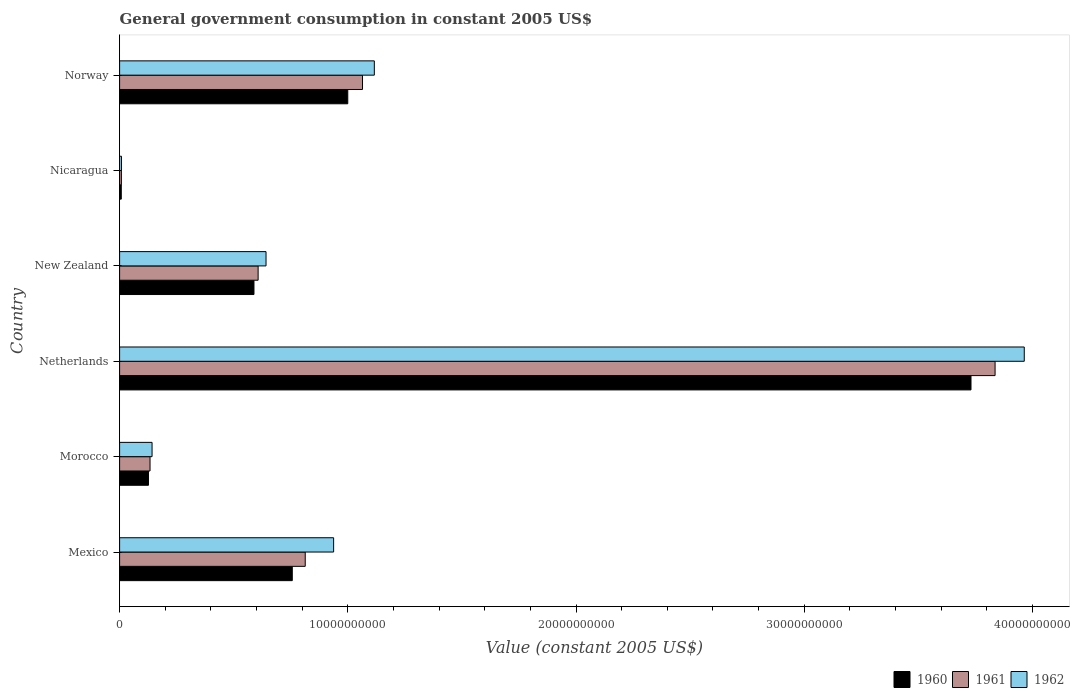How many different coloured bars are there?
Make the answer very short. 3. How many groups of bars are there?
Provide a short and direct response. 6. How many bars are there on the 3rd tick from the top?
Provide a succinct answer. 3. How many bars are there on the 6th tick from the bottom?
Your response must be concise. 3. What is the label of the 3rd group of bars from the top?
Offer a terse response. New Zealand. In how many cases, is the number of bars for a given country not equal to the number of legend labels?
Keep it short and to the point. 0. What is the government conusmption in 1961 in Norway?
Provide a short and direct response. 1.06e+1. Across all countries, what is the maximum government conusmption in 1960?
Provide a short and direct response. 3.73e+1. Across all countries, what is the minimum government conusmption in 1962?
Your answer should be compact. 8.22e+07. In which country was the government conusmption in 1961 minimum?
Provide a short and direct response. Nicaragua. What is the total government conusmption in 1960 in the graph?
Your response must be concise. 6.21e+1. What is the difference between the government conusmption in 1961 in Morocco and that in New Zealand?
Your answer should be very brief. -4.74e+09. What is the difference between the government conusmption in 1961 in New Zealand and the government conusmption in 1962 in Morocco?
Give a very brief answer. 4.65e+09. What is the average government conusmption in 1962 per country?
Your answer should be compact. 1.14e+1. What is the difference between the government conusmption in 1961 and government conusmption in 1962 in Mexico?
Your answer should be very brief. -1.24e+09. What is the ratio of the government conusmption in 1961 in Mexico to that in Morocco?
Your answer should be very brief. 6.1. Is the difference between the government conusmption in 1961 in Mexico and Netherlands greater than the difference between the government conusmption in 1962 in Mexico and Netherlands?
Give a very brief answer. Yes. What is the difference between the highest and the second highest government conusmption in 1960?
Your answer should be compact. 2.73e+1. What is the difference between the highest and the lowest government conusmption in 1962?
Offer a terse response. 3.96e+1. What does the 1st bar from the bottom in Morocco represents?
Provide a short and direct response. 1960. How many bars are there?
Ensure brevity in your answer.  18. How many countries are there in the graph?
Your answer should be compact. 6. Does the graph contain any zero values?
Ensure brevity in your answer.  No. What is the title of the graph?
Ensure brevity in your answer.  General government consumption in constant 2005 US$. Does "1962" appear as one of the legend labels in the graph?
Ensure brevity in your answer.  Yes. What is the label or title of the X-axis?
Provide a succinct answer. Value (constant 2005 US$). What is the label or title of the Y-axis?
Your response must be concise. Country. What is the Value (constant 2005 US$) of 1960 in Mexico?
Keep it short and to the point. 7.57e+09. What is the Value (constant 2005 US$) in 1961 in Mexico?
Your response must be concise. 8.13e+09. What is the Value (constant 2005 US$) of 1962 in Mexico?
Your answer should be compact. 9.38e+09. What is the Value (constant 2005 US$) in 1960 in Morocco?
Your answer should be very brief. 1.27e+09. What is the Value (constant 2005 US$) in 1961 in Morocco?
Your answer should be compact. 1.33e+09. What is the Value (constant 2005 US$) in 1962 in Morocco?
Your answer should be very brief. 1.42e+09. What is the Value (constant 2005 US$) of 1960 in Netherlands?
Keep it short and to the point. 3.73e+1. What is the Value (constant 2005 US$) in 1961 in Netherlands?
Offer a terse response. 3.84e+1. What is the Value (constant 2005 US$) in 1962 in Netherlands?
Make the answer very short. 3.96e+1. What is the Value (constant 2005 US$) of 1960 in New Zealand?
Your answer should be very brief. 5.89e+09. What is the Value (constant 2005 US$) in 1961 in New Zealand?
Ensure brevity in your answer.  6.07e+09. What is the Value (constant 2005 US$) in 1962 in New Zealand?
Your answer should be very brief. 6.42e+09. What is the Value (constant 2005 US$) in 1960 in Nicaragua?
Offer a terse response. 7.32e+07. What is the Value (constant 2005 US$) of 1961 in Nicaragua?
Make the answer very short. 7.81e+07. What is the Value (constant 2005 US$) of 1962 in Nicaragua?
Give a very brief answer. 8.22e+07. What is the Value (constant 2005 US$) of 1960 in Norway?
Provide a succinct answer. 1.00e+1. What is the Value (constant 2005 US$) in 1961 in Norway?
Your answer should be compact. 1.06e+1. What is the Value (constant 2005 US$) in 1962 in Norway?
Offer a terse response. 1.12e+1. Across all countries, what is the maximum Value (constant 2005 US$) in 1960?
Your answer should be compact. 3.73e+1. Across all countries, what is the maximum Value (constant 2005 US$) of 1961?
Your answer should be very brief. 3.84e+1. Across all countries, what is the maximum Value (constant 2005 US$) of 1962?
Your answer should be compact. 3.96e+1. Across all countries, what is the minimum Value (constant 2005 US$) of 1960?
Your response must be concise. 7.32e+07. Across all countries, what is the minimum Value (constant 2005 US$) in 1961?
Make the answer very short. 7.81e+07. Across all countries, what is the minimum Value (constant 2005 US$) of 1962?
Your answer should be compact. 8.22e+07. What is the total Value (constant 2005 US$) in 1960 in the graph?
Your answer should be compact. 6.21e+1. What is the total Value (constant 2005 US$) in 1961 in the graph?
Ensure brevity in your answer.  6.46e+1. What is the total Value (constant 2005 US$) in 1962 in the graph?
Keep it short and to the point. 6.81e+1. What is the difference between the Value (constant 2005 US$) of 1960 in Mexico and that in Morocco?
Your response must be concise. 6.30e+09. What is the difference between the Value (constant 2005 US$) in 1961 in Mexico and that in Morocco?
Provide a succinct answer. 6.80e+09. What is the difference between the Value (constant 2005 US$) in 1962 in Mexico and that in Morocco?
Offer a terse response. 7.96e+09. What is the difference between the Value (constant 2005 US$) of 1960 in Mexico and that in Netherlands?
Provide a succinct answer. -2.97e+1. What is the difference between the Value (constant 2005 US$) of 1961 in Mexico and that in Netherlands?
Give a very brief answer. -3.02e+1. What is the difference between the Value (constant 2005 US$) in 1962 in Mexico and that in Netherlands?
Your answer should be compact. -3.03e+1. What is the difference between the Value (constant 2005 US$) in 1960 in Mexico and that in New Zealand?
Your answer should be compact. 1.68e+09. What is the difference between the Value (constant 2005 US$) of 1961 in Mexico and that in New Zealand?
Your answer should be compact. 2.06e+09. What is the difference between the Value (constant 2005 US$) of 1962 in Mexico and that in New Zealand?
Make the answer very short. 2.96e+09. What is the difference between the Value (constant 2005 US$) of 1960 in Mexico and that in Nicaragua?
Provide a succinct answer. 7.49e+09. What is the difference between the Value (constant 2005 US$) in 1961 in Mexico and that in Nicaragua?
Your answer should be compact. 8.06e+09. What is the difference between the Value (constant 2005 US$) of 1962 in Mexico and that in Nicaragua?
Your answer should be very brief. 9.30e+09. What is the difference between the Value (constant 2005 US$) in 1960 in Mexico and that in Norway?
Your answer should be very brief. -2.43e+09. What is the difference between the Value (constant 2005 US$) of 1961 in Mexico and that in Norway?
Ensure brevity in your answer.  -2.51e+09. What is the difference between the Value (constant 2005 US$) in 1962 in Mexico and that in Norway?
Your answer should be compact. -1.78e+09. What is the difference between the Value (constant 2005 US$) in 1960 in Morocco and that in Netherlands?
Your answer should be compact. -3.60e+1. What is the difference between the Value (constant 2005 US$) in 1961 in Morocco and that in Netherlands?
Keep it short and to the point. -3.70e+1. What is the difference between the Value (constant 2005 US$) of 1962 in Morocco and that in Netherlands?
Offer a very short reply. -3.82e+1. What is the difference between the Value (constant 2005 US$) of 1960 in Morocco and that in New Zealand?
Provide a succinct answer. -4.62e+09. What is the difference between the Value (constant 2005 US$) of 1961 in Morocco and that in New Zealand?
Give a very brief answer. -4.74e+09. What is the difference between the Value (constant 2005 US$) of 1962 in Morocco and that in New Zealand?
Offer a terse response. -4.99e+09. What is the difference between the Value (constant 2005 US$) in 1960 in Morocco and that in Nicaragua?
Provide a succinct answer. 1.19e+09. What is the difference between the Value (constant 2005 US$) of 1961 in Morocco and that in Nicaragua?
Keep it short and to the point. 1.26e+09. What is the difference between the Value (constant 2005 US$) of 1962 in Morocco and that in Nicaragua?
Offer a very short reply. 1.34e+09. What is the difference between the Value (constant 2005 US$) in 1960 in Morocco and that in Norway?
Your answer should be compact. -8.73e+09. What is the difference between the Value (constant 2005 US$) of 1961 in Morocco and that in Norway?
Provide a short and direct response. -9.31e+09. What is the difference between the Value (constant 2005 US$) of 1962 in Morocco and that in Norway?
Offer a very short reply. -9.74e+09. What is the difference between the Value (constant 2005 US$) in 1960 in Netherlands and that in New Zealand?
Provide a short and direct response. 3.14e+1. What is the difference between the Value (constant 2005 US$) in 1961 in Netherlands and that in New Zealand?
Give a very brief answer. 3.23e+1. What is the difference between the Value (constant 2005 US$) in 1962 in Netherlands and that in New Zealand?
Keep it short and to the point. 3.32e+1. What is the difference between the Value (constant 2005 US$) in 1960 in Netherlands and that in Nicaragua?
Give a very brief answer. 3.72e+1. What is the difference between the Value (constant 2005 US$) of 1961 in Netherlands and that in Nicaragua?
Make the answer very short. 3.83e+1. What is the difference between the Value (constant 2005 US$) in 1962 in Netherlands and that in Nicaragua?
Offer a very short reply. 3.96e+1. What is the difference between the Value (constant 2005 US$) of 1960 in Netherlands and that in Norway?
Make the answer very short. 2.73e+1. What is the difference between the Value (constant 2005 US$) of 1961 in Netherlands and that in Norway?
Your response must be concise. 2.77e+1. What is the difference between the Value (constant 2005 US$) in 1962 in Netherlands and that in Norway?
Offer a very short reply. 2.85e+1. What is the difference between the Value (constant 2005 US$) of 1960 in New Zealand and that in Nicaragua?
Keep it short and to the point. 5.81e+09. What is the difference between the Value (constant 2005 US$) of 1961 in New Zealand and that in Nicaragua?
Your answer should be very brief. 5.99e+09. What is the difference between the Value (constant 2005 US$) in 1962 in New Zealand and that in Nicaragua?
Keep it short and to the point. 6.33e+09. What is the difference between the Value (constant 2005 US$) of 1960 in New Zealand and that in Norway?
Make the answer very short. -4.11e+09. What is the difference between the Value (constant 2005 US$) of 1961 in New Zealand and that in Norway?
Offer a very short reply. -4.57e+09. What is the difference between the Value (constant 2005 US$) in 1962 in New Zealand and that in Norway?
Provide a succinct answer. -4.75e+09. What is the difference between the Value (constant 2005 US$) in 1960 in Nicaragua and that in Norway?
Offer a very short reply. -9.92e+09. What is the difference between the Value (constant 2005 US$) in 1961 in Nicaragua and that in Norway?
Give a very brief answer. -1.06e+1. What is the difference between the Value (constant 2005 US$) in 1962 in Nicaragua and that in Norway?
Ensure brevity in your answer.  -1.11e+1. What is the difference between the Value (constant 2005 US$) of 1960 in Mexico and the Value (constant 2005 US$) of 1961 in Morocco?
Keep it short and to the point. 6.23e+09. What is the difference between the Value (constant 2005 US$) in 1960 in Mexico and the Value (constant 2005 US$) in 1962 in Morocco?
Give a very brief answer. 6.14e+09. What is the difference between the Value (constant 2005 US$) of 1961 in Mexico and the Value (constant 2005 US$) of 1962 in Morocco?
Give a very brief answer. 6.71e+09. What is the difference between the Value (constant 2005 US$) of 1960 in Mexico and the Value (constant 2005 US$) of 1961 in Netherlands?
Ensure brevity in your answer.  -3.08e+1. What is the difference between the Value (constant 2005 US$) in 1960 in Mexico and the Value (constant 2005 US$) in 1962 in Netherlands?
Your answer should be very brief. -3.21e+1. What is the difference between the Value (constant 2005 US$) of 1961 in Mexico and the Value (constant 2005 US$) of 1962 in Netherlands?
Your answer should be very brief. -3.15e+1. What is the difference between the Value (constant 2005 US$) in 1960 in Mexico and the Value (constant 2005 US$) in 1961 in New Zealand?
Offer a terse response. 1.50e+09. What is the difference between the Value (constant 2005 US$) of 1960 in Mexico and the Value (constant 2005 US$) of 1962 in New Zealand?
Offer a very short reply. 1.15e+09. What is the difference between the Value (constant 2005 US$) in 1961 in Mexico and the Value (constant 2005 US$) in 1962 in New Zealand?
Offer a very short reply. 1.72e+09. What is the difference between the Value (constant 2005 US$) of 1960 in Mexico and the Value (constant 2005 US$) of 1961 in Nicaragua?
Provide a succinct answer. 7.49e+09. What is the difference between the Value (constant 2005 US$) in 1960 in Mexico and the Value (constant 2005 US$) in 1962 in Nicaragua?
Your answer should be very brief. 7.48e+09. What is the difference between the Value (constant 2005 US$) of 1961 in Mexico and the Value (constant 2005 US$) of 1962 in Nicaragua?
Keep it short and to the point. 8.05e+09. What is the difference between the Value (constant 2005 US$) of 1960 in Mexico and the Value (constant 2005 US$) of 1961 in Norway?
Provide a succinct answer. -3.08e+09. What is the difference between the Value (constant 2005 US$) in 1960 in Mexico and the Value (constant 2005 US$) in 1962 in Norway?
Offer a very short reply. -3.60e+09. What is the difference between the Value (constant 2005 US$) of 1961 in Mexico and the Value (constant 2005 US$) of 1962 in Norway?
Offer a very short reply. -3.03e+09. What is the difference between the Value (constant 2005 US$) of 1960 in Morocco and the Value (constant 2005 US$) of 1961 in Netherlands?
Give a very brief answer. -3.71e+1. What is the difference between the Value (constant 2005 US$) of 1960 in Morocco and the Value (constant 2005 US$) of 1962 in Netherlands?
Make the answer very short. -3.84e+1. What is the difference between the Value (constant 2005 US$) of 1961 in Morocco and the Value (constant 2005 US$) of 1962 in Netherlands?
Your answer should be very brief. -3.83e+1. What is the difference between the Value (constant 2005 US$) in 1960 in Morocco and the Value (constant 2005 US$) in 1961 in New Zealand?
Give a very brief answer. -4.80e+09. What is the difference between the Value (constant 2005 US$) of 1960 in Morocco and the Value (constant 2005 US$) of 1962 in New Zealand?
Give a very brief answer. -5.15e+09. What is the difference between the Value (constant 2005 US$) of 1961 in Morocco and the Value (constant 2005 US$) of 1962 in New Zealand?
Your answer should be very brief. -5.08e+09. What is the difference between the Value (constant 2005 US$) of 1960 in Morocco and the Value (constant 2005 US$) of 1961 in Nicaragua?
Offer a terse response. 1.19e+09. What is the difference between the Value (constant 2005 US$) in 1960 in Morocco and the Value (constant 2005 US$) in 1962 in Nicaragua?
Your answer should be compact. 1.18e+09. What is the difference between the Value (constant 2005 US$) in 1961 in Morocco and the Value (constant 2005 US$) in 1962 in Nicaragua?
Give a very brief answer. 1.25e+09. What is the difference between the Value (constant 2005 US$) in 1960 in Morocco and the Value (constant 2005 US$) in 1961 in Norway?
Provide a succinct answer. -9.38e+09. What is the difference between the Value (constant 2005 US$) of 1960 in Morocco and the Value (constant 2005 US$) of 1962 in Norway?
Provide a short and direct response. -9.90e+09. What is the difference between the Value (constant 2005 US$) in 1961 in Morocco and the Value (constant 2005 US$) in 1962 in Norway?
Offer a very short reply. -9.83e+09. What is the difference between the Value (constant 2005 US$) of 1960 in Netherlands and the Value (constant 2005 US$) of 1961 in New Zealand?
Offer a terse response. 3.12e+1. What is the difference between the Value (constant 2005 US$) in 1960 in Netherlands and the Value (constant 2005 US$) in 1962 in New Zealand?
Offer a very short reply. 3.09e+1. What is the difference between the Value (constant 2005 US$) of 1961 in Netherlands and the Value (constant 2005 US$) of 1962 in New Zealand?
Your answer should be very brief. 3.19e+1. What is the difference between the Value (constant 2005 US$) of 1960 in Netherlands and the Value (constant 2005 US$) of 1961 in Nicaragua?
Give a very brief answer. 3.72e+1. What is the difference between the Value (constant 2005 US$) of 1960 in Netherlands and the Value (constant 2005 US$) of 1962 in Nicaragua?
Offer a very short reply. 3.72e+1. What is the difference between the Value (constant 2005 US$) of 1961 in Netherlands and the Value (constant 2005 US$) of 1962 in Nicaragua?
Provide a succinct answer. 3.83e+1. What is the difference between the Value (constant 2005 US$) in 1960 in Netherlands and the Value (constant 2005 US$) in 1961 in Norway?
Your answer should be compact. 2.67e+1. What is the difference between the Value (constant 2005 US$) of 1960 in Netherlands and the Value (constant 2005 US$) of 1962 in Norway?
Keep it short and to the point. 2.61e+1. What is the difference between the Value (constant 2005 US$) of 1961 in Netherlands and the Value (constant 2005 US$) of 1962 in Norway?
Give a very brief answer. 2.72e+1. What is the difference between the Value (constant 2005 US$) in 1960 in New Zealand and the Value (constant 2005 US$) in 1961 in Nicaragua?
Provide a succinct answer. 5.81e+09. What is the difference between the Value (constant 2005 US$) in 1960 in New Zealand and the Value (constant 2005 US$) in 1962 in Nicaragua?
Offer a very short reply. 5.81e+09. What is the difference between the Value (constant 2005 US$) in 1961 in New Zealand and the Value (constant 2005 US$) in 1962 in Nicaragua?
Provide a succinct answer. 5.99e+09. What is the difference between the Value (constant 2005 US$) in 1960 in New Zealand and the Value (constant 2005 US$) in 1961 in Norway?
Make the answer very short. -4.76e+09. What is the difference between the Value (constant 2005 US$) in 1960 in New Zealand and the Value (constant 2005 US$) in 1962 in Norway?
Make the answer very short. -5.27e+09. What is the difference between the Value (constant 2005 US$) in 1961 in New Zealand and the Value (constant 2005 US$) in 1962 in Norway?
Ensure brevity in your answer.  -5.09e+09. What is the difference between the Value (constant 2005 US$) in 1960 in Nicaragua and the Value (constant 2005 US$) in 1961 in Norway?
Give a very brief answer. -1.06e+1. What is the difference between the Value (constant 2005 US$) in 1960 in Nicaragua and the Value (constant 2005 US$) in 1962 in Norway?
Provide a succinct answer. -1.11e+1. What is the difference between the Value (constant 2005 US$) of 1961 in Nicaragua and the Value (constant 2005 US$) of 1962 in Norway?
Give a very brief answer. -1.11e+1. What is the average Value (constant 2005 US$) in 1960 per country?
Your answer should be compact. 1.03e+1. What is the average Value (constant 2005 US$) in 1961 per country?
Make the answer very short. 1.08e+1. What is the average Value (constant 2005 US$) of 1962 per country?
Provide a succinct answer. 1.14e+1. What is the difference between the Value (constant 2005 US$) in 1960 and Value (constant 2005 US$) in 1961 in Mexico?
Provide a succinct answer. -5.68e+08. What is the difference between the Value (constant 2005 US$) of 1960 and Value (constant 2005 US$) of 1962 in Mexico?
Provide a short and direct response. -1.81e+09. What is the difference between the Value (constant 2005 US$) in 1961 and Value (constant 2005 US$) in 1962 in Mexico?
Your answer should be compact. -1.24e+09. What is the difference between the Value (constant 2005 US$) of 1960 and Value (constant 2005 US$) of 1961 in Morocco?
Provide a succinct answer. -6.82e+07. What is the difference between the Value (constant 2005 US$) in 1960 and Value (constant 2005 US$) in 1962 in Morocco?
Your response must be concise. -1.57e+08. What is the difference between the Value (constant 2005 US$) in 1961 and Value (constant 2005 US$) in 1962 in Morocco?
Your answer should be very brief. -8.90e+07. What is the difference between the Value (constant 2005 US$) in 1960 and Value (constant 2005 US$) in 1961 in Netherlands?
Offer a terse response. -1.06e+09. What is the difference between the Value (constant 2005 US$) in 1960 and Value (constant 2005 US$) in 1962 in Netherlands?
Ensure brevity in your answer.  -2.33e+09. What is the difference between the Value (constant 2005 US$) of 1961 and Value (constant 2005 US$) of 1962 in Netherlands?
Your response must be concise. -1.28e+09. What is the difference between the Value (constant 2005 US$) in 1960 and Value (constant 2005 US$) in 1961 in New Zealand?
Provide a succinct answer. -1.82e+08. What is the difference between the Value (constant 2005 US$) in 1960 and Value (constant 2005 US$) in 1962 in New Zealand?
Your answer should be very brief. -5.28e+08. What is the difference between the Value (constant 2005 US$) of 1961 and Value (constant 2005 US$) of 1962 in New Zealand?
Ensure brevity in your answer.  -3.46e+08. What is the difference between the Value (constant 2005 US$) of 1960 and Value (constant 2005 US$) of 1961 in Nicaragua?
Your answer should be very brief. -4.90e+06. What is the difference between the Value (constant 2005 US$) of 1960 and Value (constant 2005 US$) of 1962 in Nicaragua?
Ensure brevity in your answer.  -8.94e+06. What is the difference between the Value (constant 2005 US$) in 1961 and Value (constant 2005 US$) in 1962 in Nicaragua?
Provide a short and direct response. -4.04e+06. What is the difference between the Value (constant 2005 US$) of 1960 and Value (constant 2005 US$) of 1961 in Norway?
Offer a very short reply. -6.46e+08. What is the difference between the Value (constant 2005 US$) of 1960 and Value (constant 2005 US$) of 1962 in Norway?
Give a very brief answer. -1.16e+09. What is the difference between the Value (constant 2005 US$) in 1961 and Value (constant 2005 US$) in 1962 in Norway?
Provide a short and direct response. -5.18e+08. What is the ratio of the Value (constant 2005 US$) in 1960 in Mexico to that in Morocco?
Your answer should be very brief. 5.98. What is the ratio of the Value (constant 2005 US$) of 1961 in Mexico to that in Morocco?
Make the answer very short. 6.1. What is the ratio of the Value (constant 2005 US$) in 1962 in Mexico to that in Morocco?
Your response must be concise. 6.59. What is the ratio of the Value (constant 2005 US$) of 1960 in Mexico to that in Netherlands?
Your answer should be very brief. 0.2. What is the ratio of the Value (constant 2005 US$) in 1961 in Mexico to that in Netherlands?
Give a very brief answer. 0.21. What is the ratio of the Value (constant 2005 US$) in 1962 in Mexico to that in Netherlands?
Your answer should be compact. 0.24. What is the ratio of the Value (constant 2005 US$) of 1960 in Mexico to that in New Zealand?
Ensure brevity in your answer.  1.29. What is the ratio of the Value (constant 2005 US$) in 1961 in Mexico to that in New Zealand?
Your response must be concise. 1.34. What is the ratio of the Value (constant 2005 US$) of 1962 in Mexico to that in New Zealand?
Keep it short and to the point. 1.46. What is the ratio of the Value (constant 2005 US$) in 1960 in Mexico to that in Nicaragua?
Ensure brevity in your answer.  103.32. What is the ratio of the Value (constant 2005 US$) of 1961 in Mexico to that in Nicaragua?
Provide a short and direct response. 104.11. What is the ratio of the Value (constant 2005 US$) of 1962 in Mexico to that in Nicaragua?
Your response must be concise. 114.13. What is the ratio of the Value (constant 2005 US$) of 1960 in Mexico to that in Norway?
Ensure brevity in your answer.  0.76. What is the ratio of the Value (constant 2005 US$) of 1961 in Mexico to that in Norway?
Keep it short and to the point. 0.76. What is the ratio of the Value (constant 2005 US$) of 1962 in Mexico to that in Norway?
Offer a terse response. 0.84. What is the ratio of the Value (constant 2005 US$) in 1960 in Morocco to that in Netherlands?
Ensure brevity in your answer.  0.03. What is the ratio of the Value (constant 2005 US$) in 1961 in Morocco to that in Netherlands?
Give a very brief answer. 0.03. What is the ratio of the Value (constant 2005 US$) of 1962 in Morocco to that in Netherlands?
Make the answer very short. 0.04. What is the ratio of the Value (constant 2005 US$) in 1960 in Morocco to that in New Zealand?
Give a very brief answer. 0.21. What is the ratio of the Value (constant 2005 US$) of 1961 in Morocco to that in New Zealand?
Provide a short and direct response. 0.22. What is the ratio of the Value (constant 2005 US$) in 1962 in Morocco to that in New Zealand?
Ensure brevity in your answer.  0.22. What is the ratio of the Value (constant 2005 US$) of 1960 in Morocco to that in Nicaragua?
Ensure brevity in your answer.  17.28. What is the ratio of the Value (constant 2005 US$) in 1961 in Morocco to that in Nicaragua?
Make the answer very short. 17.07. What is the ratio of the Value (constant 2005 US$) in 1962 in Morocco to that in Nicaragua?
Keep it short and to the point. 17.31. What is the ratio of the Value (constant 2005 US$) in 1960 in Morocco to that in Norway?
Your answer should be very brief. 0.13. What is the ratio of the Value (constant 2005 US$) in 1961 in Morocco to that in Norway?
Offer a terse response. 0.13. What is the ratio of the Value (constant 2005 US$) in 1962 in Morocco to that in Norway?
Offer a terse response. 0.13. What is the ratio of the Value (constant 2005 US$) in 1960 in Netherlands to that in New Zealand?
Offer a terse response. 6.34. What is the ratio of the Value (constant 2005 US$) of 1961 in Netherlands to that in New Zealand?
Make the answer very short. 6.32. What is the ratio of the Value (constant 2005 US$) of 1962 in Netherlands to that in New Zealand?
Give a very brief answer. 6.18. What is the ratio of the Value (constant 2005 US$) in 1960 in Netherlands to that in Nicaragua?
Make the answer very short. 509.43. What is the ratio of the Value (constant 2005 US$) in 1961 in Netherlands to that in Nicaragua?
Ensure brevity in your answer.  490.98. What is the ratio of the Value (constant 2005 US$) in 1962 in Netherlands to that in Nicaragua?
Make the answer very short. 482.42. What is the ratio of the Value (constant 2005 US$) of 1960 in Netherlands to that in Norway?
Provide a succinct answer. 3.73. What is the ratio of the Value (constant 2005 US$) in 1961 in Netherlands to that in Norway?
Your response must be concise. 3.6. What is the ratio of the Value (constant 2005 US$) of 1962 in Netherlands to that in Norway?
Provide a short and direct response. 3.55. What is the ratio of the Value (constant 2005 US$) of 1960 in New Zealand to that in Nicaragua?
Make the answer very short. 80.4. What is the ratio of the Value (constant 2005 US$) in 1961 in New Zealand to that in Nicaragua?
Your answer should be compact. 77.68. What is the ratio of the Value (constant 2005 US$) in 1962 in New Zealand to that in Nicaragua?
Give a very brief answer. 78.08. What is the ratio of the Value (constant 2005 US$) in 1960 in New Zealand to that in Norway?
Offer a very short reply. 0.59. What is the ratio of the Value (constant 2005 US$) in 1961 in New Zealand to that in Norway?
Offer a terse response. 0.57. What is the ratio of the Value (constant 2005 US$) in 1962 in New Zealand to that in Norway?
Provide a succinct answer. 0.57. What is the ratio of the Value (constant 2005 US$) of 1960 in Nicaragua to that in Norway?
Ensure brevity in your answer.  0.01. What is the ratio of the Value (constant 2005 US$) of 1961 in Nicaragua to that in Norway?
Give a very brief answer. 0.01. What is the ratio of the Value (constant 2005 US$) of 1962 in Nicaragua to that in Norway?
Keep it short and to the point. 0.01. What is the difference between the highest and the second highest Value (constant 2005 US$) of 1960?
Your answer should be very brief. 2.73e+1. What is the difference between the highest and the second highest Value (constant 2005 US$) of 1961?
Offer a terse response. 2.77e+1. What is the difference between the highest and the second highest Value (constant 2005 US$) in 1962?
Provide a short and direct response. 2.85e+1. What is the difference between the highest and the lowest Value (constant 2005 US$) of 1960?
Your response must be concise. 3.72e+1. What is the difference between the highest and the lowest Value (constant 2005 US$) in 1961?
Your response must be concise. 3.83e+1. What is the difference between the highest and the lowest Value (constant 2005 US$) of 1962?
Provide a succinct answer. 3.96e+1. 